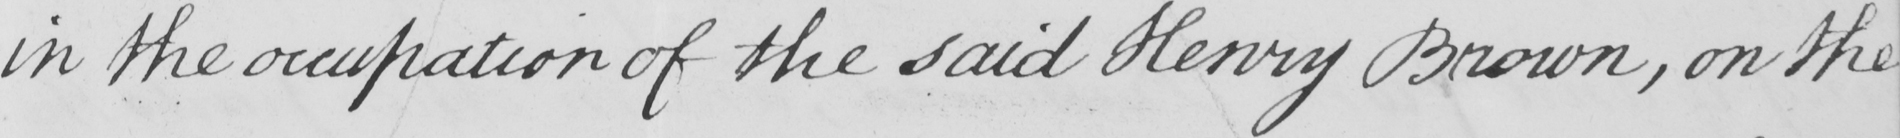What is written in this line of handwriting? in the occupation of the said Henry Brown , on the 